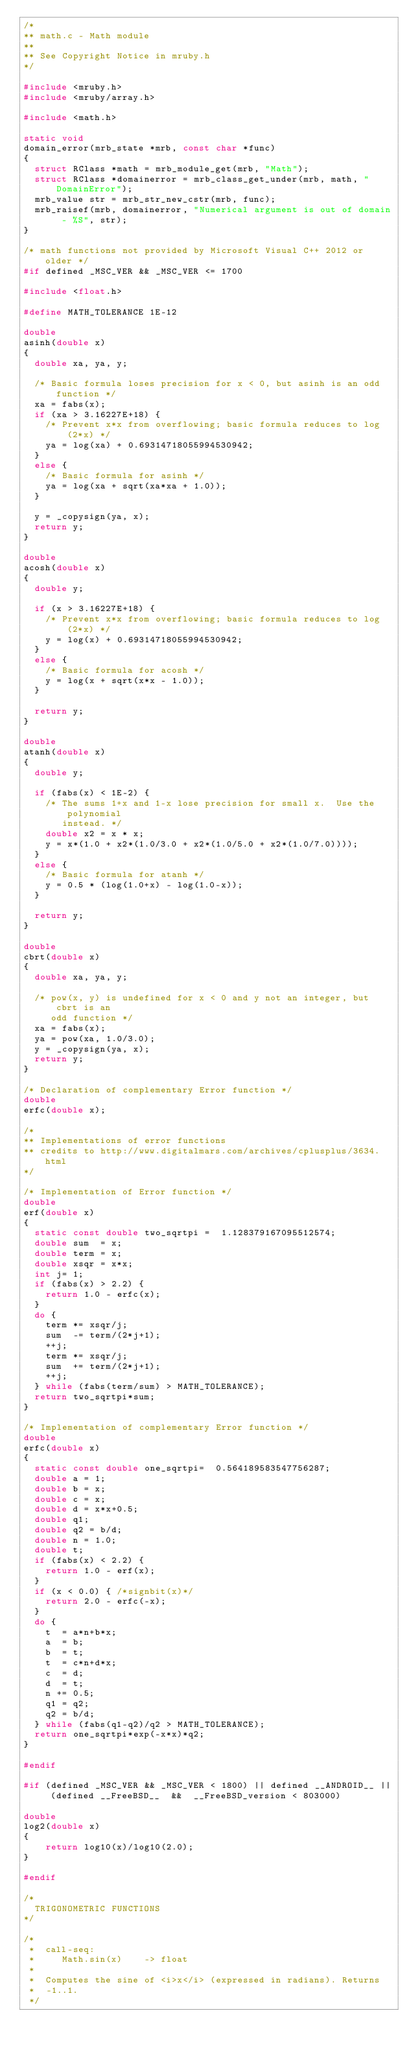<code> <loc_0><loc_0><loc_500><loc_500><_C_>/*
** math.c - Math module
**
** See Copyright Notice in mruby.h
*/

#include <mruby.h>
#include <mruby/array.h>

#include <math.h>

static void
domain_error(mrb_state *mrb, const char *func)
{
  struct RClass *math = mrb_module_get(mrb, "Math");
  struct RClass *domainerror = mrb_class_get_under(mrb, math, "DomainError");
  mrb_value str = mrb_str_new_cstr(mrb, func);
  mrb_raisef(mrb, domainerror, "Numerical argument is out of domain - %S", str);
}

/* math functions not provided by Microsoft Visual C++ 2012 or older */
#if defined _MSC_VER && _MSC_VER <= 1700

#include <float.h>

#define MATH_TOLERANCE 1E-12

double
asinh(double x)
{
  double xa, ya, y;

  /* Basic formula loses precision for x < 0, but asinh is an odd function */
  xa = fabs(x);
  if (xa > 3.16227E+18) {
    /* Prevent x*x from overflowing; basic formula reduces to log(2*x) */
    ya = log(xa) + 0.69314718055994530942;
  }
  else {
    /* Basic formula for asinh */
    ya = log(xa + sqrt(xa*xa + 1.0));
  }

  y = _copysign(ya, x);
  return y;
}

double
acosh(double x)
{
  double y;

  if (x > 3.16227E+18) {
    /* Prevent x*x from overflowing; basic formula reduces to log(2*x) */
    y = log(x) + 0.69314718055994530942;
  }
  else {
    /* Basic formula for acosh */
    y = log(x + sqrt(x*x - 1.0));
  }

  return y;
}

double
atanh(double x)
{
  double y;

  if (fabs(x) < 1E-2) {
    /* The sums 1+x and 1-x lose precision for small x.  Use the polynomial
       instead. */
    double x2 = x * x;
    y = x*(1.0 + x2*(1.0/3.0 + x2*(1.0/5.0 + x2*(1.0/7.0))));
  }
  else {
    /* Basic formula for atanh */
    y = 0.5 * (log(1.0+x) - log(1.0-x));
  }

  return y;
}

double
cbrt(double x)
{
  double xa, ya, y;

  /* pow(x, y) is undefined for x < 0 and y not an integer, but cbrt is an
     odd function */
  xa = fabs(x);
  ya = pow(xa, 1.0/3.0);
  y = _copysign(ya, x);
  return y;
}

/* Declaration of complementary Error function */
double
erfc(double x);

/*
** Implementations of error functions
** credits to http://www.digitalmars.com/archives/cplusplus/3634.html
*/

/* Implementation of Error function */
double
erf(double x)
{
  static const double two_sqrtpi =  1.128379167095512574;
  double sum  = x;
  double term = x;
  double xsqr = x*x;
  int j= 1;
  if (fabs(x) > 2.2) {
    return 1.0 - erfc(x);
  }
  do {
    term *= xsqr/j;
    sum  -= term/(2*j+1);
    ++j;
    term *= xsqr/j;
    sum  += term/(2*j+1);
    ++j;
  } while (fabs(term/sum) > MATH_TOLERANCE);
  return two_sqrtpi*sum;
}

/* Implementation of complementary Error function */
double
erfc(double x)
{
  static const double one_sqrtpi=  0.564189583547756287;
  double a = 1;
  double b = x;
  double c = x;
  double d = x*x+0.5;
  double q1;
  double q2 = b/d;
  double n = 1.0;
  double t;
  if (fabs(x) < 2.2) {
    return 1.0 - erf(x);
  }
  if (x < 0.0) { /*signbit(x)*/
    return 2.0 - erfc(-x);
  }
  do {
    t  = a*n+b*x;
    a  = b;
    b  = t;
    t  = c*n+d*x;
    c  = d;
    d  = t;
    n += 0.5;
    q1 = q2;
    q2 = b/d;
  } while (fabs(q1-q2)/q2 > MATH_TOLERANCE);
  return one_sqrtpi*exp(-x*x)*q2;
}

#endif

#if (defined _MSC_VER && _MSC_VER < 1800) || defined __ANDROID__ || (defined __FreeBSD__  &&  __FreeBSD_version < 803000)

double
log2(double x)
{
    return log10(x)/log10(2.0);
}

#endif

/*
  TRIGONOMETRIC FUNCTIONS
*/

/*
 *  call-seq:
 *     Math.sin(x)    -> float
 *
 *  Computes the sine of <i>x</i> (expressed in radians). Returns
 *  -1..1.
 */</code> 